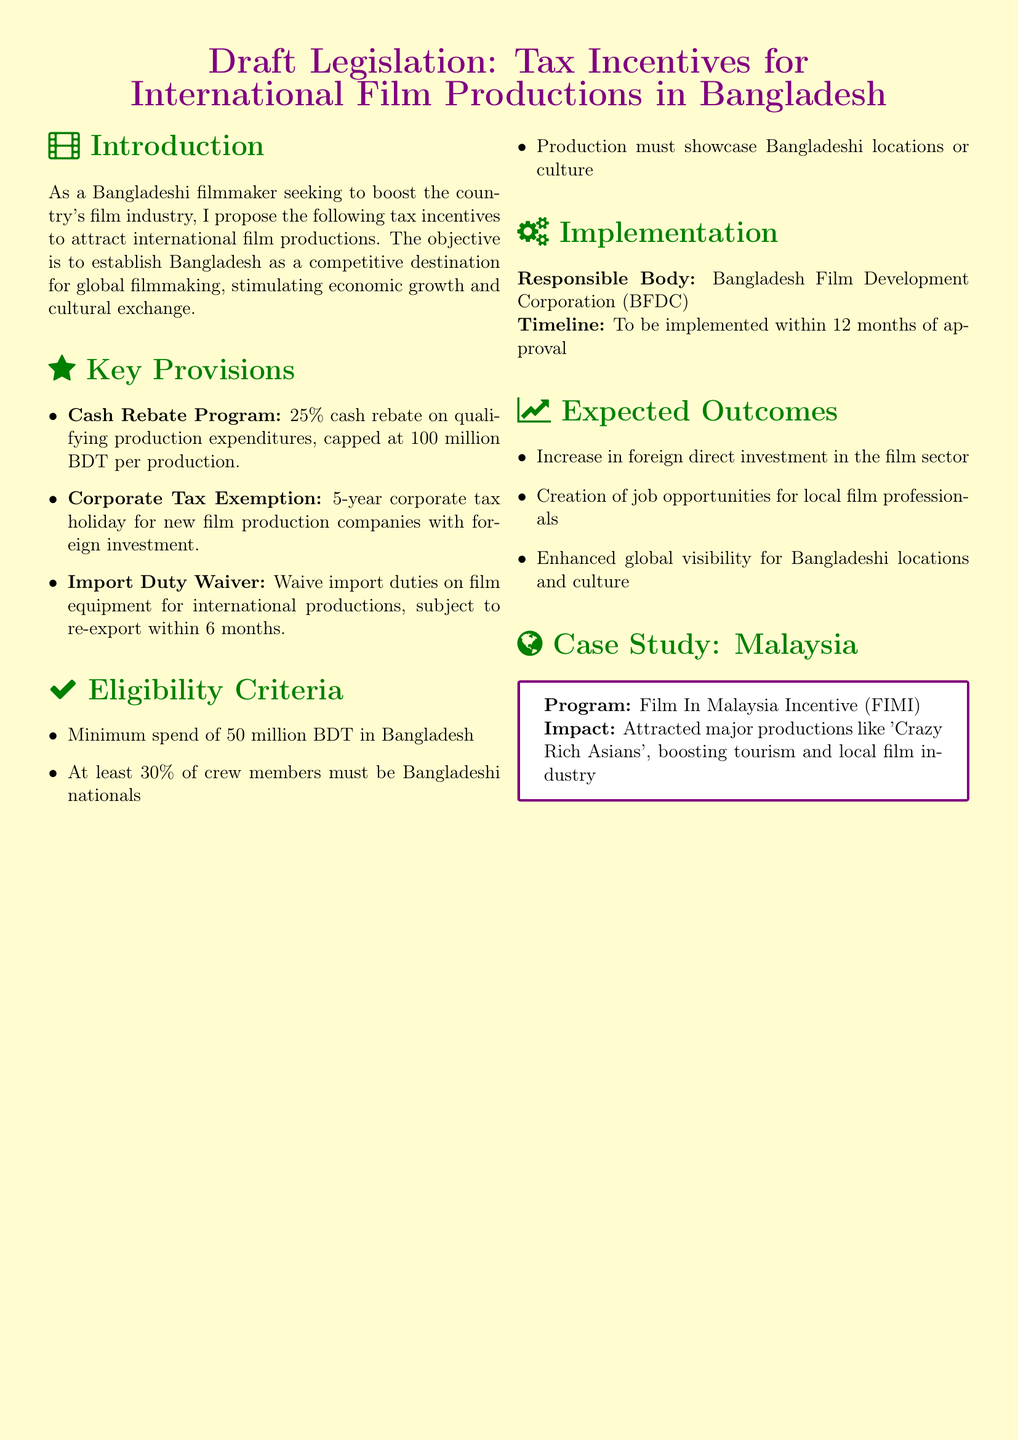What is the cash rebate percentage for productions? The document states there is a 25% cash rebate on qualifying production expenditures.
Answer: 25% What is the corporate tax holiday duration for new film production companies? The document indicates a 5-year corporate tax holiday for new film production companies with foreign investment.
Answer: 5 years What is the minimum spend required in Bangladesh? The document mentions a minimum spend of 50 million BDT in Bangladesh for eligibility.
Answer: 50 million BDT Which body is responsible for implementing the proposed tax incentives? The responsible body for implementation as stated in the document is the Bangladesh Film Development Corporation (BFDC).
Answer: BFDC What is the expected outcome related to job opportunities? The document lists the creation of job opportunities for local film professionals as an expected outcome.
Answer: Job opportunities What percentage of crew members must be Bangladeshi nationals? It is required that at least 30% of crew members must be Bangladeshi nationals according to the eligibility criteria.
Answer: 30% What international program is referenced as a case study? The document provides a case study of the Film In Malaysia Incentive (FIMI) program.
Answer: Film In Malaysia Incentive What is the cap for the cash rebate program? The document specifies that the cash rebate is capped at 100 million BDT per production.
Answer: 100 million BDT What is the timeline for implementation after approval? The timeline mentioned for implementation is within 12 months of approval.
Answer: 12 months 